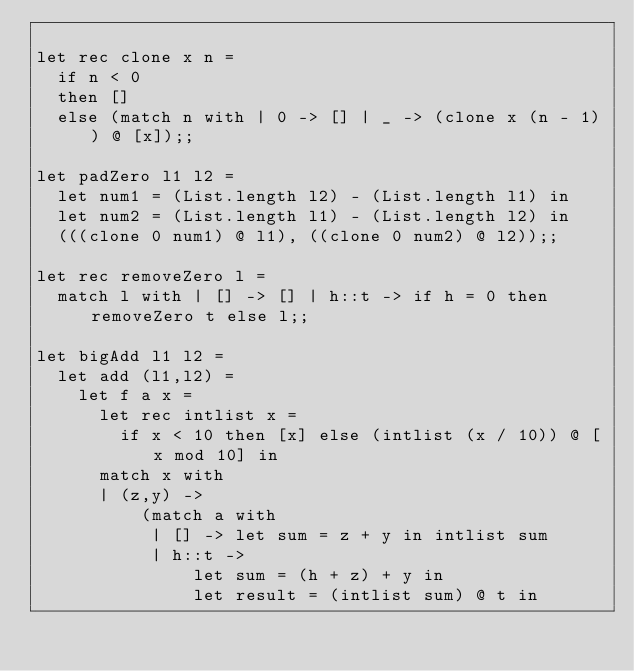Convert code to text. <code><loc_0><loc_0><loc_500><loc_500><_OCaml_>
let rec clone x n =
  if n < 0
  then []
  else (match n with | 0 -> [] | _ -> (clone x (n - 1)) @ [x]);;

let padZero l1 l2 =
  let num1 = (List.length l2) - (List.length l1) in
  let num2 = (List.length l1) - (List.length l2) in
  (((clone 0 num1) @ l1), ((clone 0 num2) @ l2));;

let rec removeZero l =
  match l with | [] -> [] | h::t -> if h = 0 then removeZero t else l;;

let bigAdd l1 l2 =
  let add (l1,l2) =
    let f a x =
      let rec intlist x =
        if x < 10 then [x] else (intlist (x / 10)) @ [x mod 10] in
      match x with
      | (z,y) ->
          (match a with
           | [] -> let sum = z + y in intlist sum
           | h::t ->
               let sum = (h + z) + y in
               let result = (intlist sum) @ t in</code> 